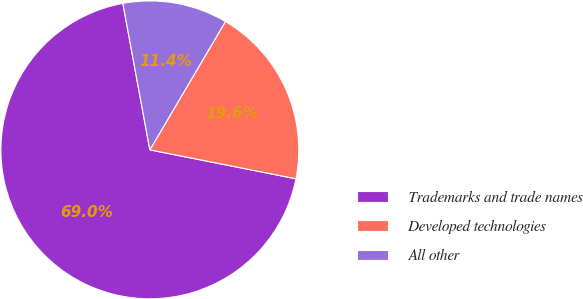Convert chart to OTSL. <chart><loc_0><loc_0><loc_500><loc_500><pie_chart><fcel>Trademarks and trade names<fcel>Developed technologies<fcel>All other<nl><fcel>68.99%<fcel>19.64%<fcel>11.37%<nl></chart> 